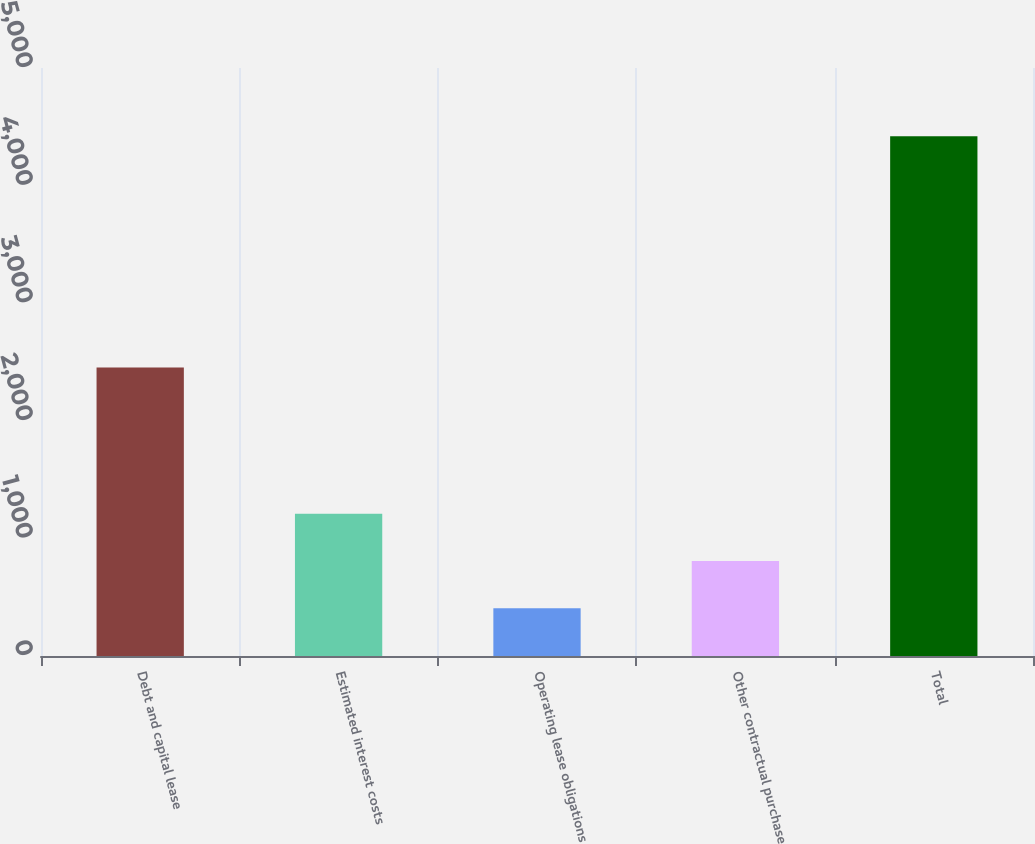<chart> <loc_0><loc_0><loc_500><loc_500><bar_chart><fcel>Debt and capital lease<fcel>Estimated interest costs<fcel>Operating lease obligations<fcel>Other contractual purchase<fcel>Total<nl><fcel>2453<fcel>1208.6<fcel>406<fcel>807.3<fcel>4419<nl></chart> 